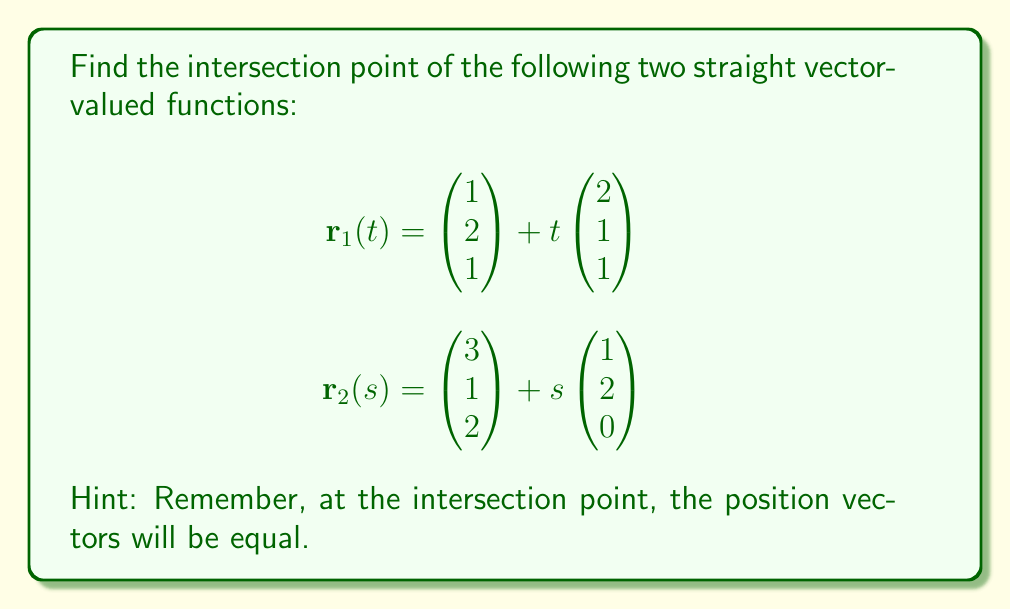Give your solution to this math problem. To find the intersection point, we need to set the two vector-valued functions equal to each other and solve for the parameters $t$ and $s$. Let's break this down into steps:

1) Set $\mathbf{r}_1(t) = \mathbf{r}_2(s)$:

   $$\begin{pmatrix} 1 \\ 2 \\ 1 \end{pmatrix} + t\begin{pmatrix} 2 \\ 1 \\ 1 \end{pmatrix} = \begin{pmatrix} 3 \\ 1 \\ 2 \end{pmatrix} + s\begin{pmatrix} 1 \\ 2 \\ 0 \end{pmatrix}$$

2) This gives us three equations:

   $1 + 2t = 3 + s$
   $2 + t = 1 + 2s$
   $1 + t = 2$

3) From the third equation, we can immediately see that $t = 1$.

4) Substituting $t = 1$ into the first equation:

   $1 + 2(1) = 3 + s$
   $3 = 3 + s$
   $s = 0$

5) We can verify this solution using the second equation:

   $2 + 1 = 1 + 2(0)$
   $3 = 1$

6) Now that we have $t = 1$ and $s = 0$, we can find the intersection point by substituting either of these values into their respective vector-valued functions. Let's use $\mathbf{r}_1(t)$:

   $$\mathbf{r}_1(1) = \begin{pmatrix} 1 \\ 2 \\ 1 \end{pmatrix} + 1\begin{pmatrix} 2 \\ 1 \\ 1 \end{pmatrix} = \begin{pmatrix} 1+2 \\ 2+1 \\ 1+1 \end{pmatrix} = \begin{pmatrix} 3 \\ 3 \\ 2 \end{pmatrix}$$

Therefore, the intersection point is $(3, 3, 2)$.
Answer: The intersection point is $(3, 3, 2)$. 